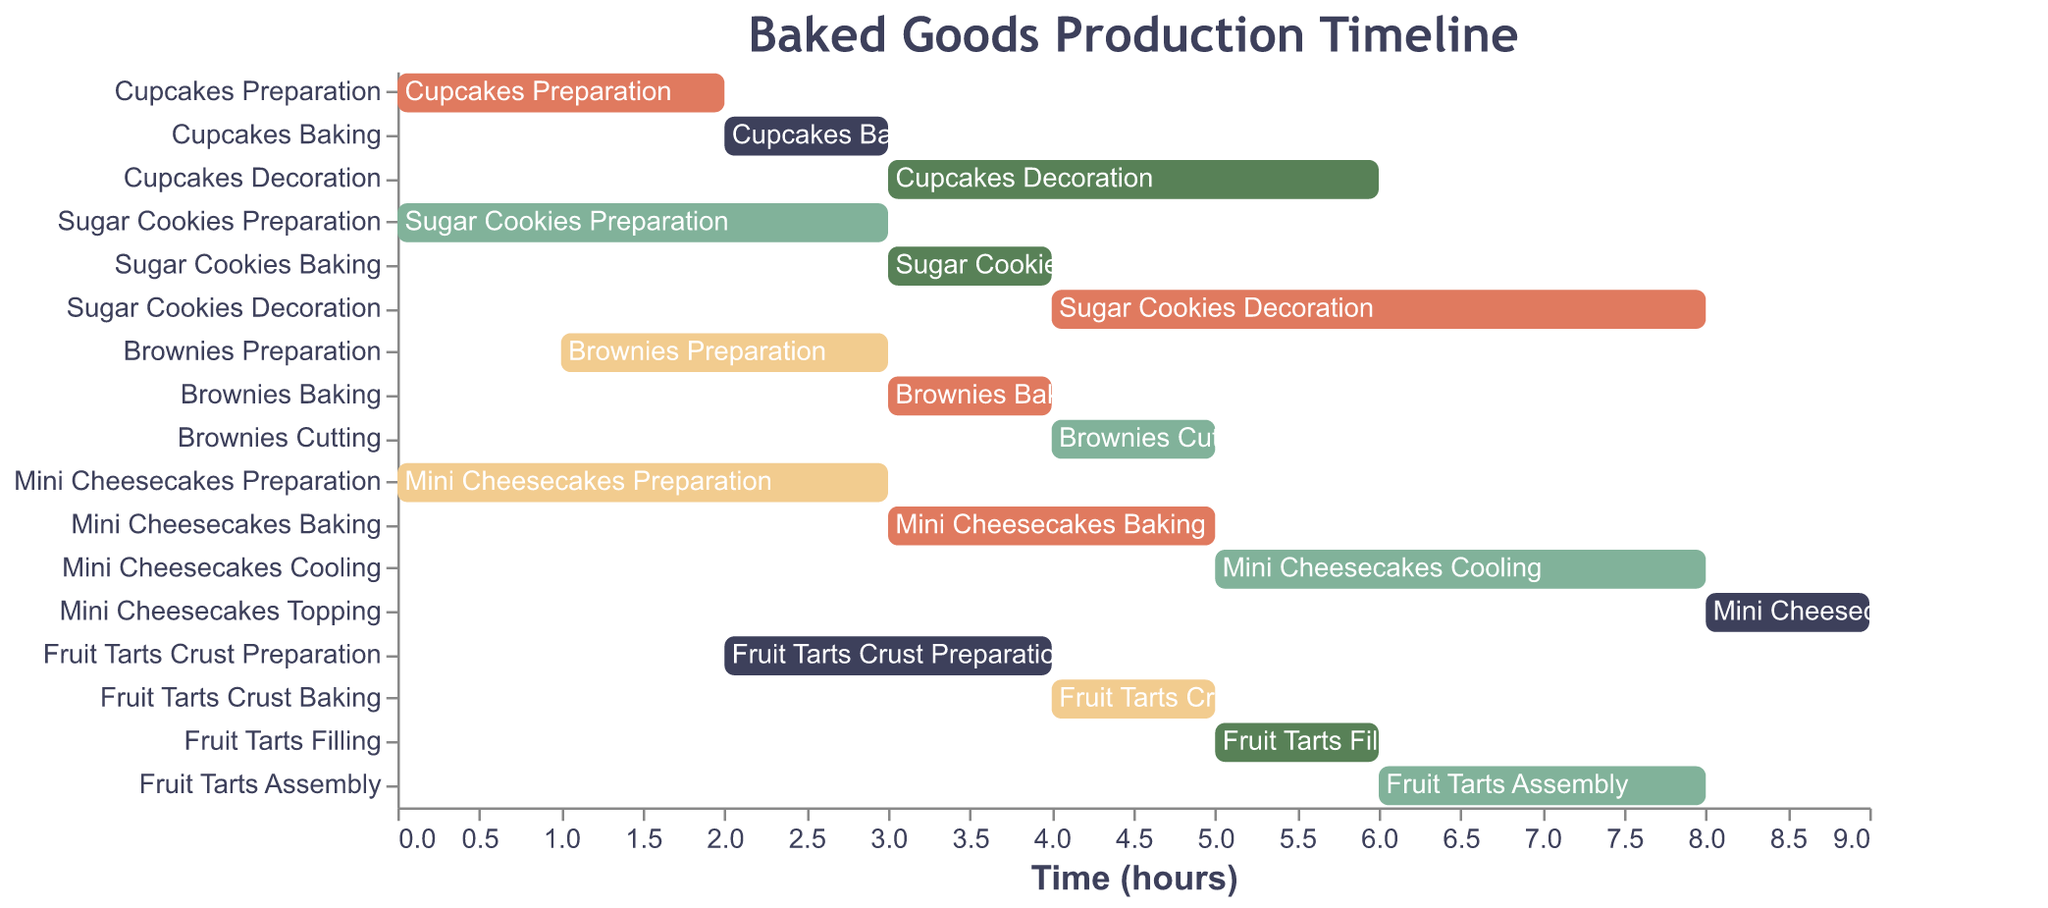What's the total duration for decorating the Sugar Cookies? To find the total duration for decorating the Sugar Cookies, we refer to the task "Sugar Cookies Decoration," which shows the duration directly in the figure.
Answer: 4 hours How many different preparation tasks take place at hour 0? At hour 0, refer to the "Start" column to count the tasks that begin at this time. Cupcakes Preparation, Sugar Cookies Preparation, and Mini Cheesecakes Preparation all start at hour 0.
Answer: 3 tasks Which task takes the longest time to complete, and how long is it? Look for the task with the maximum duration. The tasks are colored bars labeled with their durations. "Sugar Cookies Decoration" is the task with the longest duration, which is 4 hours.
Answer: Sugar Cookies Decoration, 4 hours At which hour does the baking of Mini Cheesecakes start and end? For the Mini Cheesecakes Baking, look at its Start and Duration. The start is at hour 3 and takes 2 hours to bake, so it ends at hour 5.
Answer: Starts at hour 3, ends at hour 5 Compare the total production time of Cupcakes to that of Brownies. Sum up the durations of all tasks associated with each item. Cupcakes: Preparation (2) + Baking (1) + Decoration (3) = 6 hours. Brownies: Preparation (2) + Baking (1) + Cutting (1) = 4 hours.
Answer: Cupcakes take 6 hours, Brownies take 4 hours How long does it take to fully complete the Mini Cheesecakes? Sum up the duration of all tasks for Mini Cheesecakes: Preparation (3), Baking (2), Cooling (3), Topping (1). Therefore, 3 + 2 + 3 + 1 = 9 hours.
Answer: 9 hours Which type of baked good starts its first task the latest? Refer to the "Start" times of the first task for each type of baked good. The latest start time is for Fruit Tarts at hour 2.
Answer: Fruit Tarts During which hours are the most tasks running concurrently? Examine the timeline and count the number of tasks running concurrently at each hour. The highest number is in the hours between 3 and 4, where multiple tasks overlap.
Answer: Between hours 3 and 4 What's the duration between the start of the first and the last task for Cupcakes? The Cupcakes tasks start at hour 0 (Preparation) and end at hour 6 (Decoration). The gap between the first and last tasks is 6-0 = 6 hours.
Answer: 6 hours 